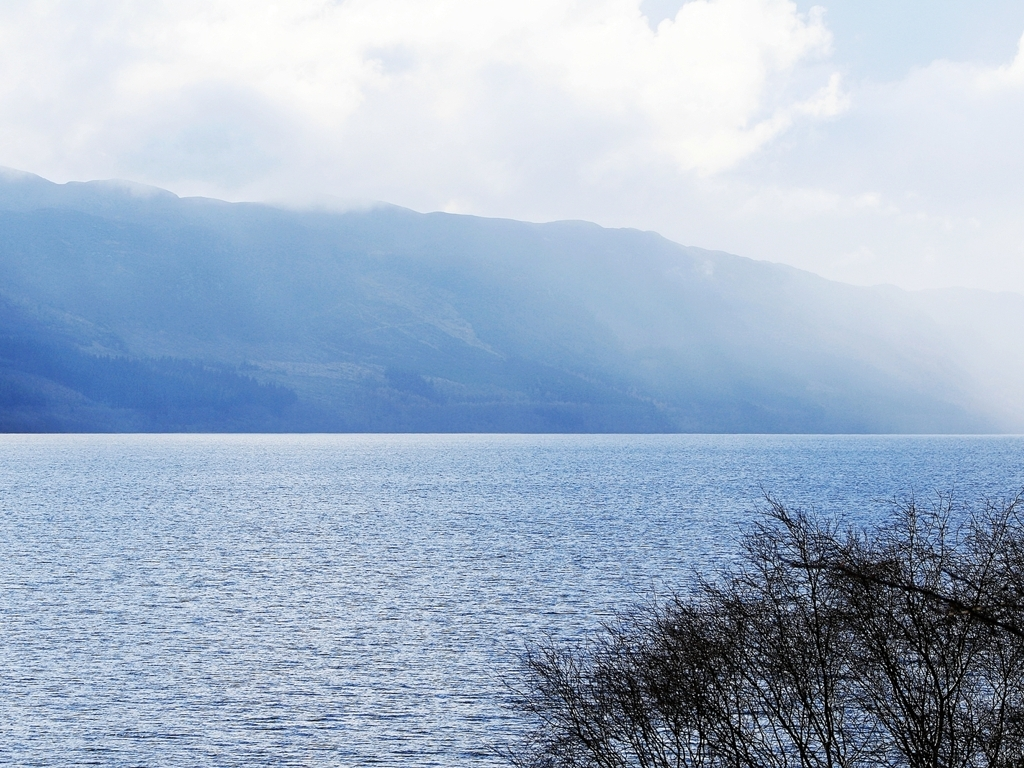Are there any quality issues with this image? Yes, there are some quality issues with this image. It appears slightly overexposed in the sky area, which lacks detail and makes it appear washed out. Moreover, there is a noticeable haze over the mountains, reducing contrast and clarity. While these could be atmospheric conditions, they affect the overall sharpness of the image. 